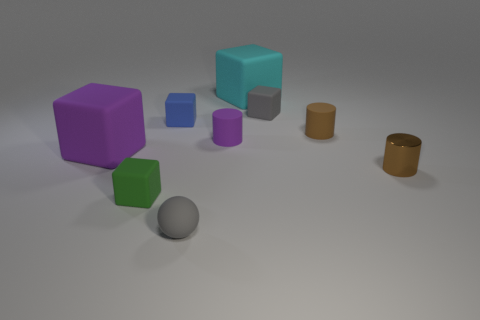There is a tiny brown object that is behind the purple rubber object that is right of the tiny gray rubber thing left of the cyan rubber object; what shape is it?
Give a very brief answer. Cylinder. There is a large rubber thing that is to the right of the gray ball; is its shape the same as the gray thing that is right of the small purple rubber thing?
Give a very brief answer. Yes. How many other objects are there of the same material as the gray cube?
Your response must be concise. 7. What is the shape of the small green object that is the same material as the small purple object?
Keep it short and to the point. Cube. Do the cyan matte object and the green rubber thing have the same size?
Provide a short and direct response. No. There is a matte thing behind the tiny gray object behind the small gray matte sphere; what is its size?
Your response must be concise. Large. What shape is the rubber object that is the same color as the metal thing?
Keep it short and to the point. Cylinder. What number of balls are either tiny matte things or small gray things?
Your answer should be very brief. 1. Do the metallic object and the cyan block behind the large purple matte thing have the same size?
Your answer should be very brief. No. Are there more large purple rubber blocks that are in front of the small brown matte object than gray things?
Make the answer very short. No. 